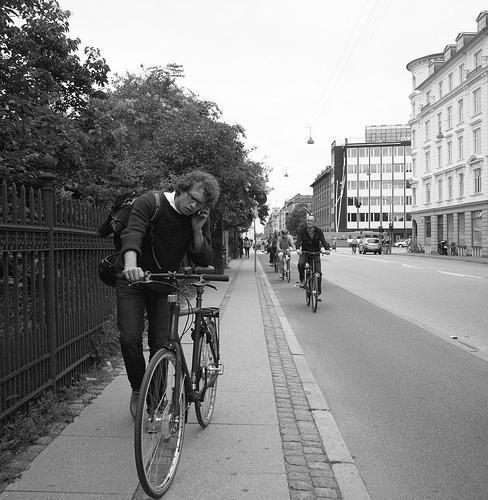How many bicycles on sidewalk?
Give a very brief answer. 1. How many people walking beside their bikes?
Give a very brief answer. 1. 